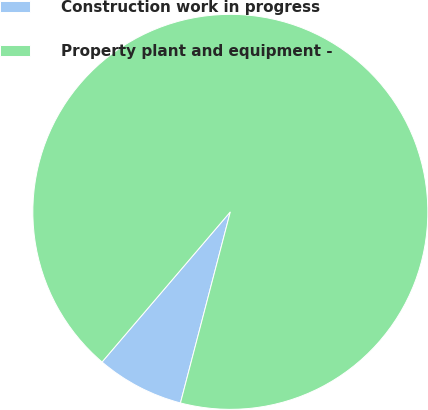<chart> <loc_0><loc_0><loc_500><loc_500><pie_chart><fcel>Construction work in progress<fcel>Property plant and equipment -<nl><fcel>7.19%<fcel>92.81%<nl></chart> 